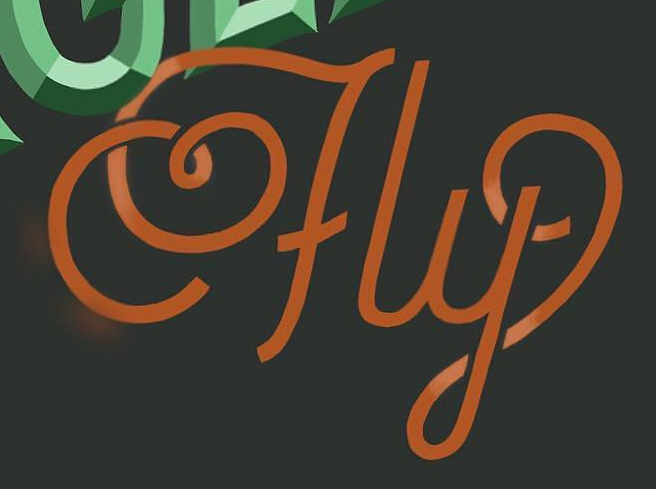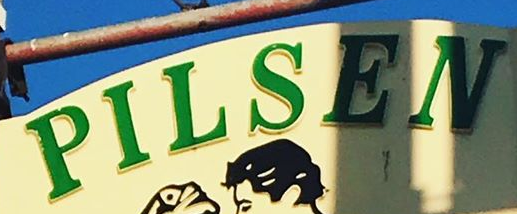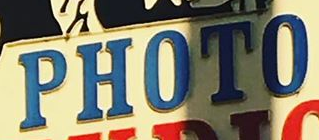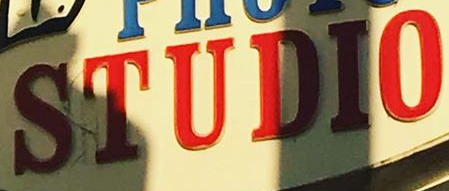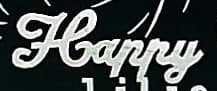Transcribe the words shown in these images in order, separated by a semicolon. fly; PILSEN; PHOTO; STUDIO; Happy 